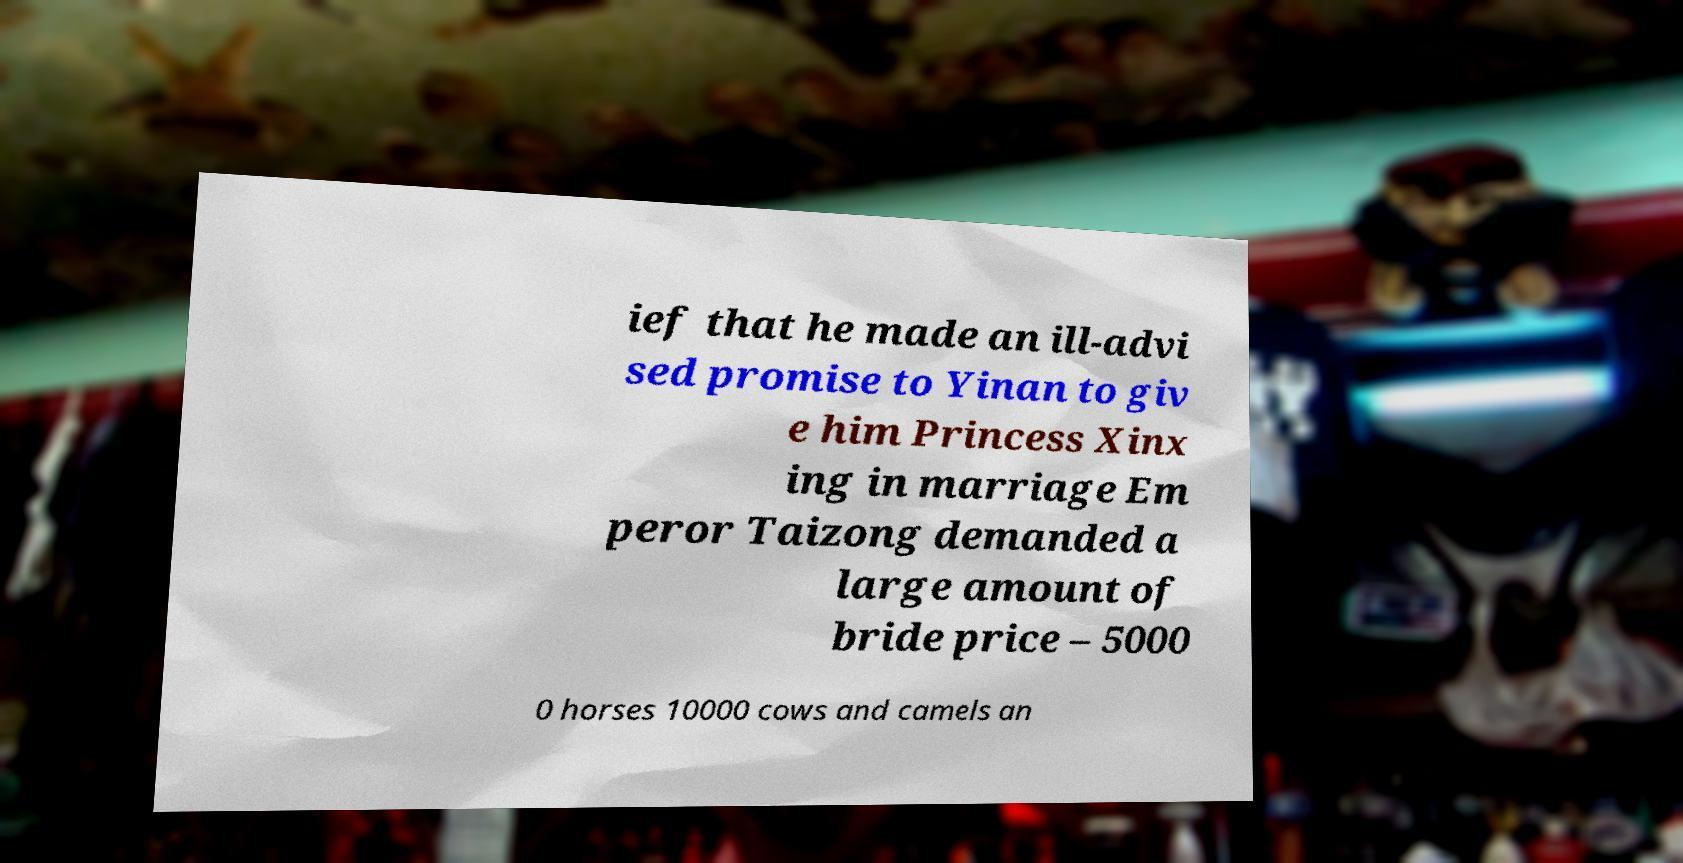Can you read and provide the text displayed in the image?This photo seems to have some interesting text. Can you extract and type it out for me? ief that he made an ill-advi sed promise to Yinan to giv e him Princess Xinx ing in marriage Em peror Taizong demanded a large amount of bride price – 5000 0 horses 10000 cows and camels an 